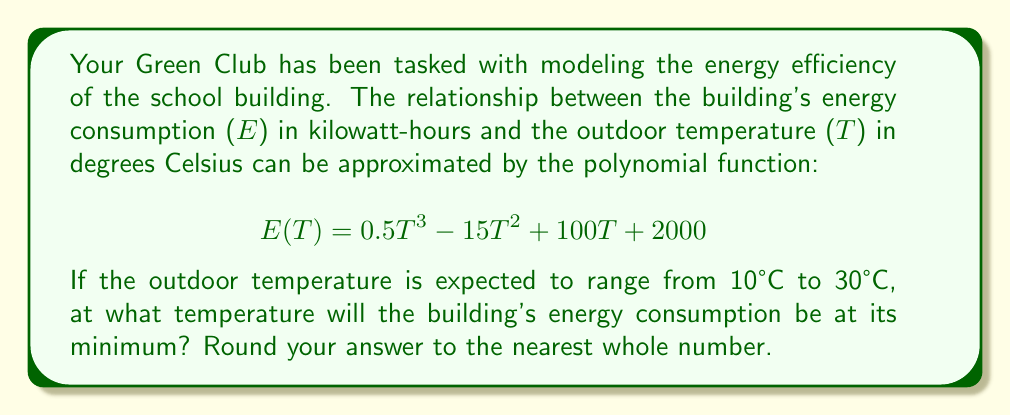Solve this math problem. To find the temperature at which the building's energy consumption is at its minimum, we need to follow these steps:

1) The minimum point of the function occurs where its derivative equals zero. Let's find the derivative of E(T):

   $$E'(T) = 1.5T^2 - 30T + 100$$

2) Set the derivative equal to zero and solve for T:

   $$1.5T^2 - 30T + 100 = 0$$

3) This is a quadratic equation. We can solve it using the quadratic formula:

   $$T = \frac{-b \pm \sqrt{b^2 - 4ac}}{2a}$$

   Where $a = 1.5$, $b = -30$, and $c = 100$

4) Substituting these values:

   $$T = \frac{30 \pm \sqrt{(-30)^2 - 4(1.5)(100)}}{2(1.5)}$$

   $$T = \frac{30 \pm \sqrt{900 - 600}}{3}$$

   $$T = \frac{30 \pm \sqrt{300}}{3}$$

   $$T = \frac{30 \pm 10\sqrt{3}}{3}$$

5) This gives us two solutions:

   $$T_1 = \frac{30 + 10\sqrt{3}}{3} \approx 15.77$$
   $$T_2 = \frac{30 - 10\sqrt{3}}{3} \approx 4.23$$

6) Since the question states that the temperature ranges from 10°C to 30°C, we can discard the second solution.

7) Rounding 15.77 to the nearest whole number gives us 16.

Therefore, the building's energy consumption will be at its minimum when the outdoor temperature is approximately 16°C.
Answer: 16°C 